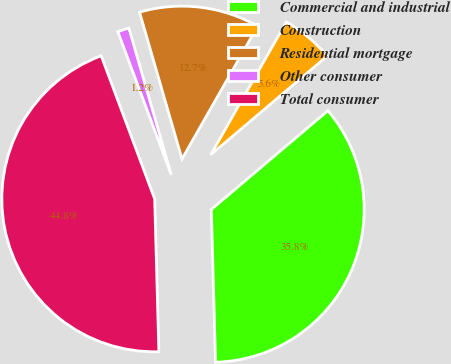Convert chart. <chart><loc_0><loc_0><loc_500><loc_500><pie_chart><fcel>Commercial and industrial<fcel>Construction<fcel>Residential mortgage<fcel>Other consumer<fcel>Total consumer<nl><fcel>35.75%<fcel>5.57%<fcel>12.72%<fcel>1.21%<fcel>44.75%<nl></chart> 